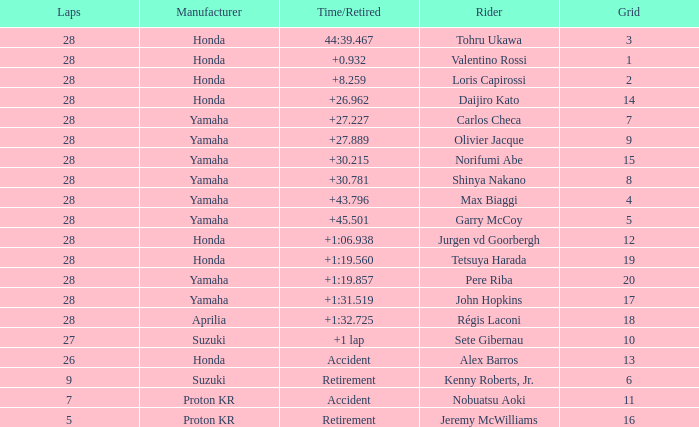How many laps were in grid 4? 28.0. 